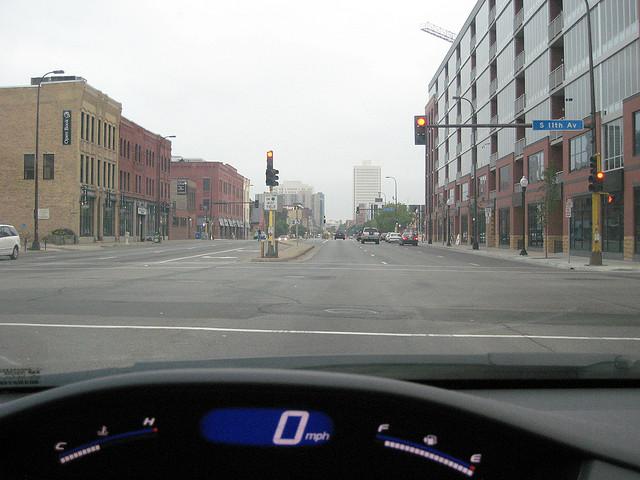When will the light change?
Answer briefly. Soon. What does it say on the dashboard?
Short answer required. 0 mph. When were these stoplights installed in the picture?
Answer briefly. Years ago. 